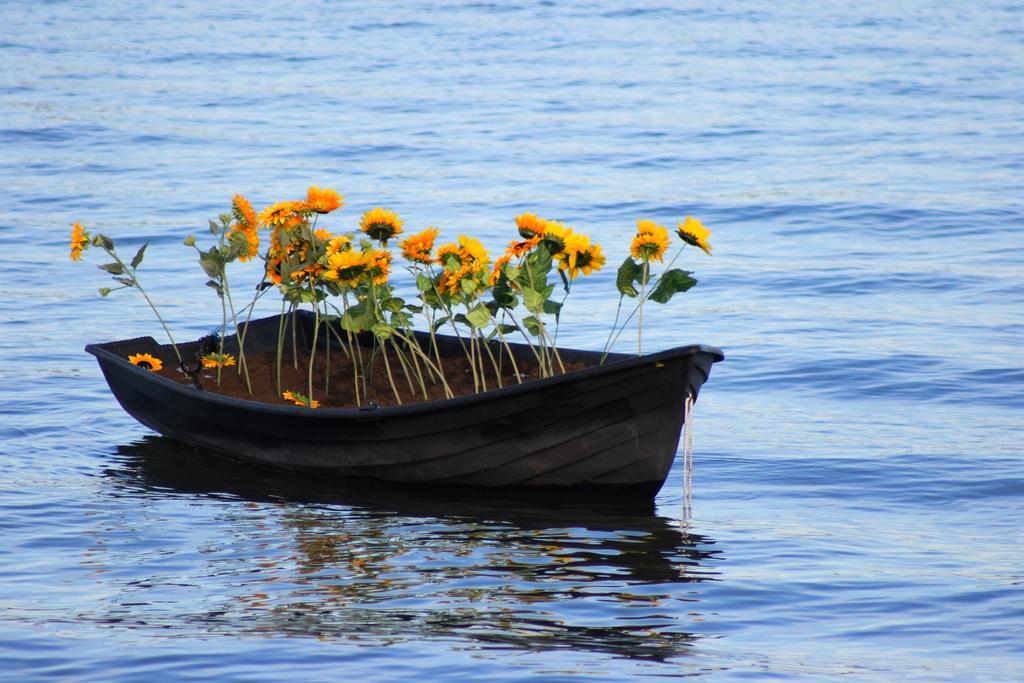How would you summarize this image in a sentence or two? In this image there is a boat. In the boat there are few plants having flowers. The boat is sailing on water. 